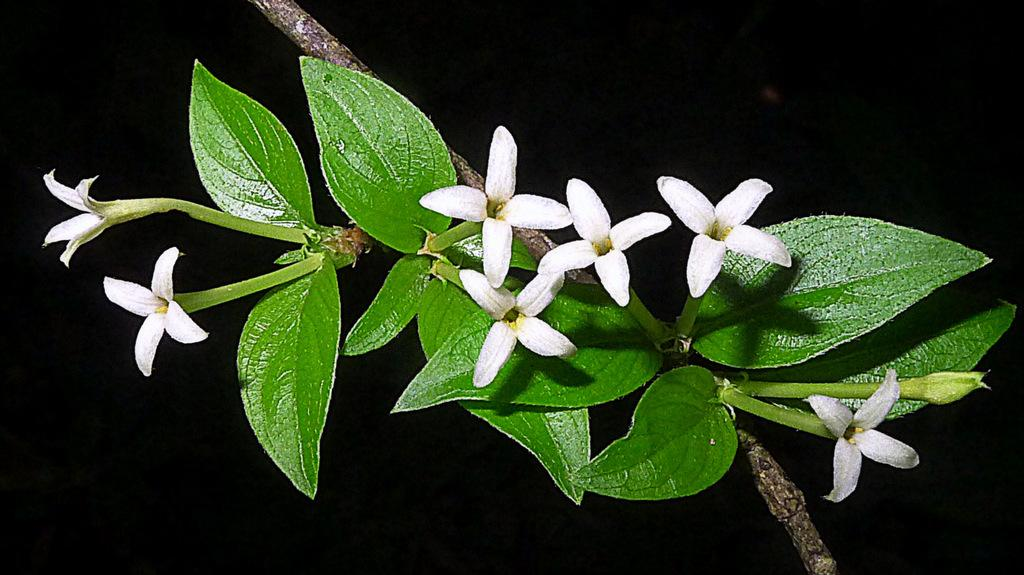What type of plant is in the image? There is a small white color flower plant in the image. What color are the leaves of the flower plant? The flower plant has green leaves. Where is the flower plant located in the image? The flower plant is in the front of the image. What can be seen behind the flower plant in the image? There is a dark background in the image. How does the flower plant contribute to the profit of the company in the image? There is no company or profit mentioned in the image; it simply features a small white color flower plant with green leaves. 